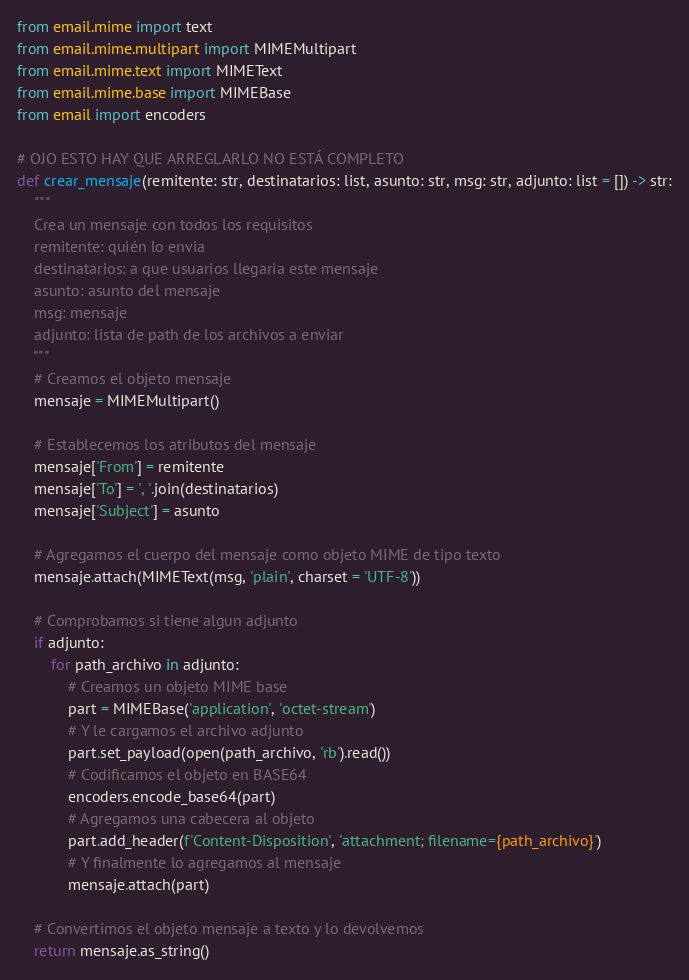Convert code to text. <code><loc_0><loc_0><loc_500><loc_500><_Python_>from email.mime import text
from email.mime.multipart import MIMEMultipart
from email.mime.text import MIMEText
from email.mime.base import MIMEBase
from email import encoders

# OJO ESTO HAY QUE ARREGLARLO NO ESTÁ COMPLETO
def crear_mensaje(remitente: str, destinatarios: list, asunto: str, msg: str, adjunto: list = []) -> str:
    """
    Crea un mensaje con todos los requisitos 
    remitente: quién lo envia
    destinatarios: a que usuarios llegaria este mensaje
    asunto: asunto del mensaje
    msg: mensaje
    adjunto: lista de path de los archivos a enviar  
    """
    # Creamos el objeto mensaje
    mensaje = MIMEMultipart()

    # Establecemos los atributos del mensaje
    mensaje['From'] = remitente
    mensaje['To'] = ', '.join(destinatarios)
    mensaje['Subject'] = asunto

    # Agregamos el cuerpo del mensaje como objeto MIME de tipo texto
    mensaje.attach(MIMEText(msg, 'plain', charset = 'UTF-8'))
    
    # Comprobamos si tiene algun adjunto  
    if adjunto:
        for path_archivo in adjunto:
            # Creamos un objeto MIME base
            part = MIMEBase('application', 'octet-stream')
            # Y le cargamos el archivo adjunto
            part.set_payload(open(path_archivo, 'rb').read())
            # Codificamos el objeto en BASE64
            encoders.encode_base64(part)
            # Agregamos una cabecera al objeto
            part.add_header(f'Content-Disposition', 'attachment; filename={path_archivo}')
            # Y finalmente lo agregamos al mensaje
            mensaje.attach(part)
    
    # Convertimos el objeto mensaje a texto y lo devolvemos
    return mensaje.as_string()</code> 